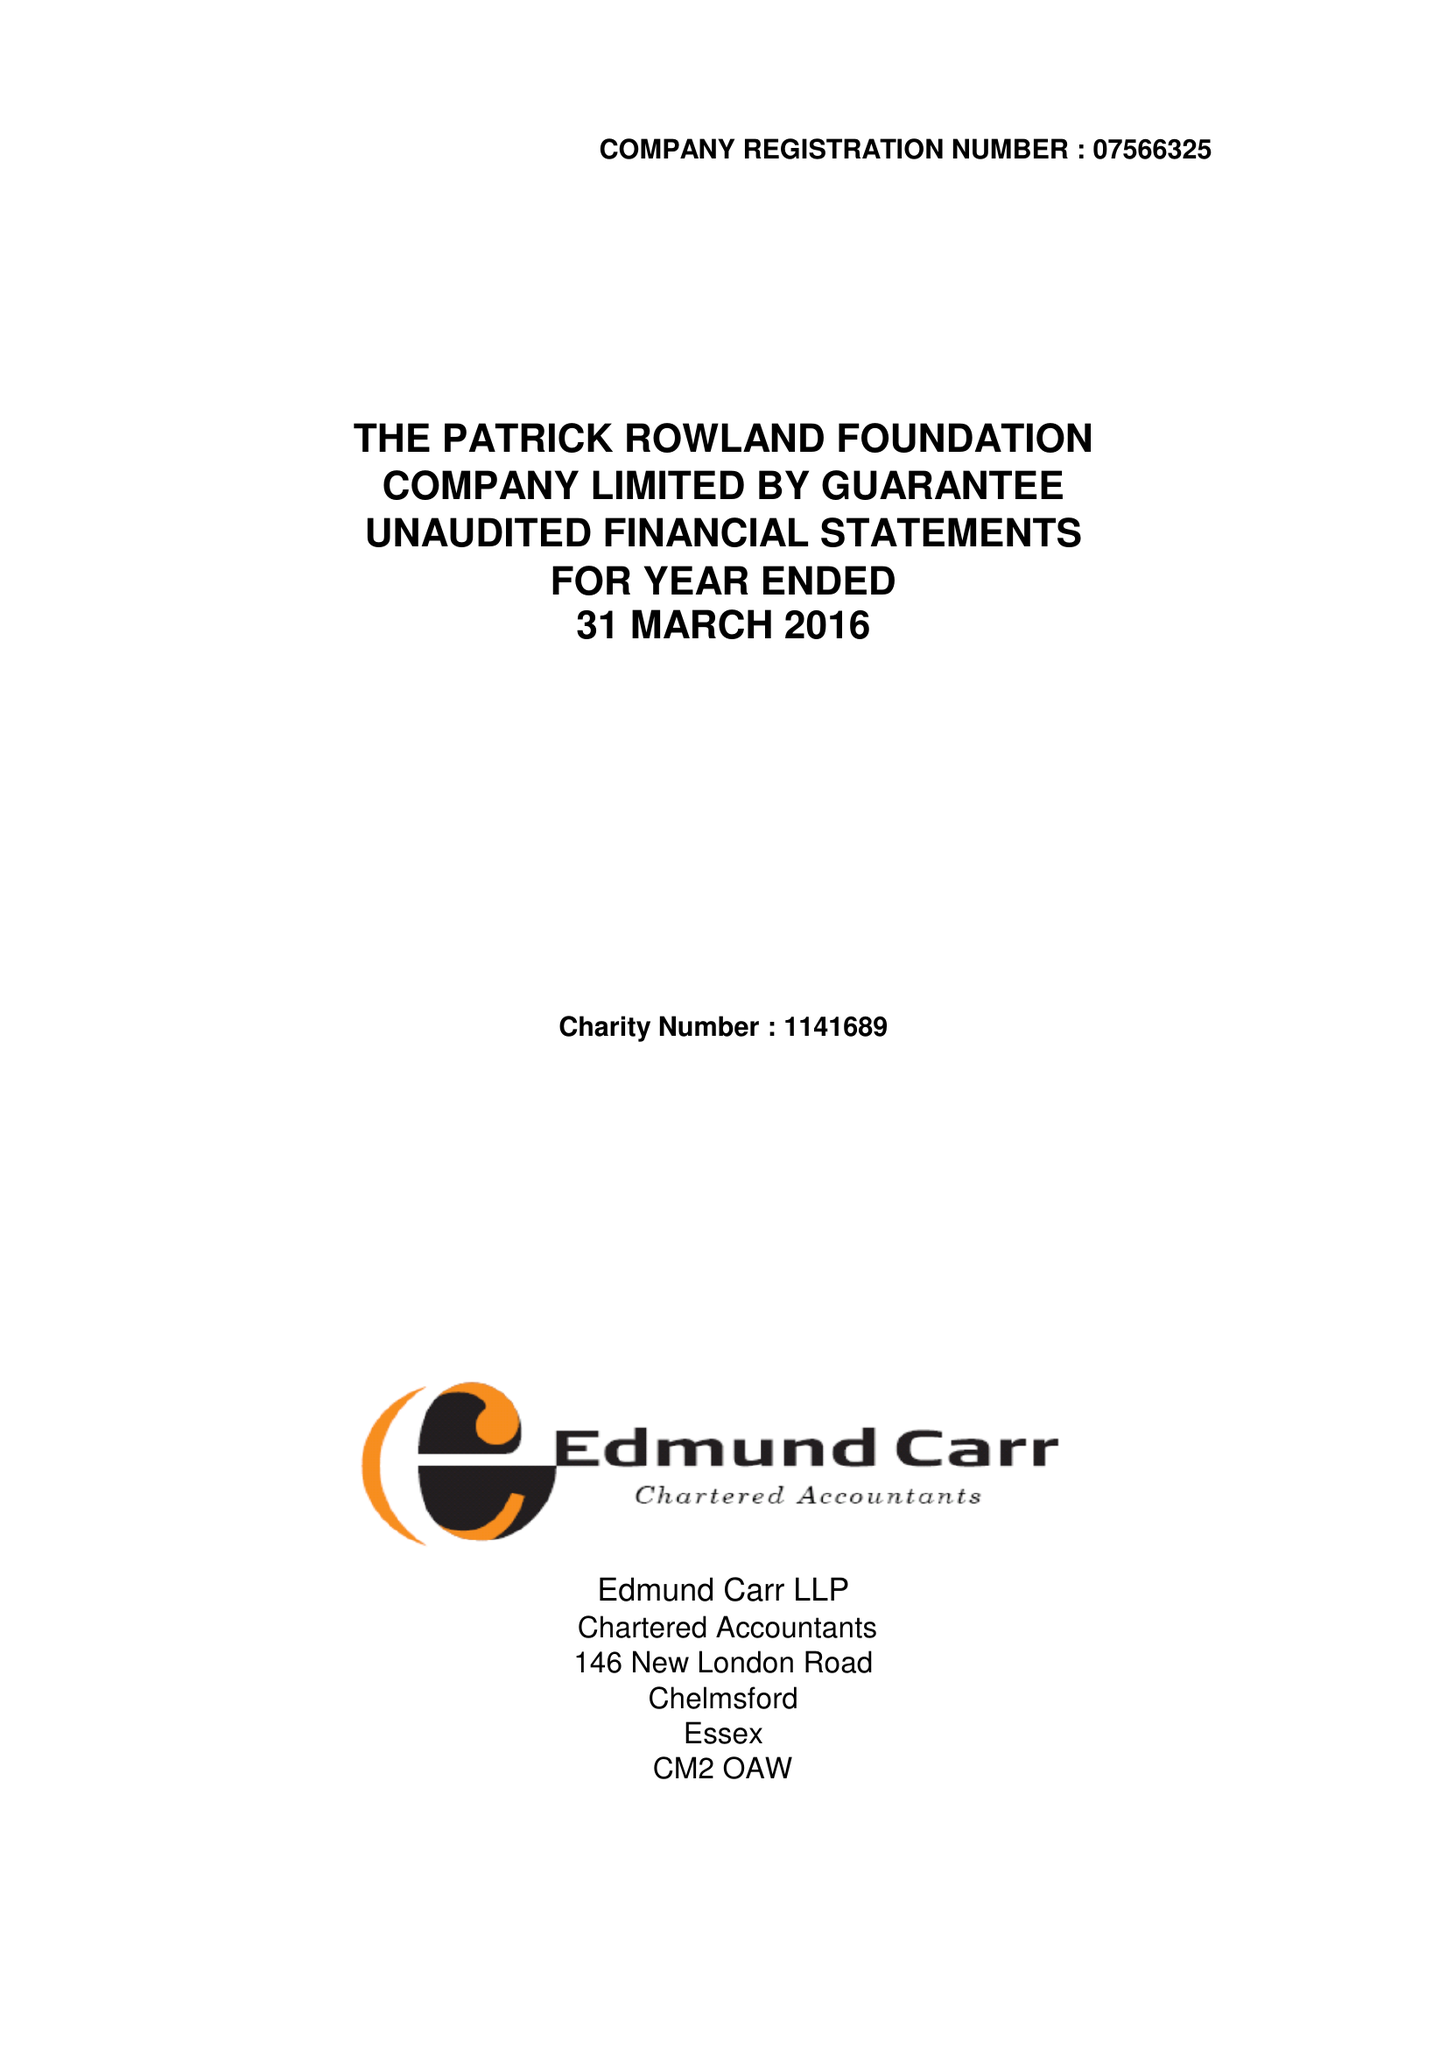What is the value for the report_date?
Answer the question using a single word or phrase. 2016-03-31 